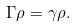<formula> <loc_0><loc_0><loc_500><loc_500>\Gamma \rho = \gamma \rho .</formula> 